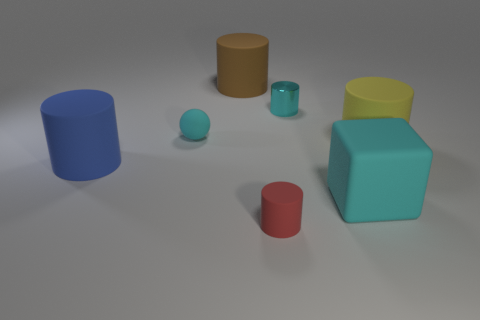Are there any cyan matte spheres of the same size as the yellow cylinder?
Your answer should be very brief. No. There is a thing right of the rubber block; what material is it?
Offer a terse response. Rubber. Do the small cylinder that is behind the blue object and the brown object have the same material?
Your answer should be compact. No. Are there any large blocks?
Give a very brief answer. Yes. The small cylinder that is the same material as the big cyan thing is what color?
Offer a terse response. Red. There is a small rubber object behind the tiny thing that is in front of the cyan matte object to the right of the tiny red thing; what color is it?
Ensure brevity in your answer.  Cyan. Is the size of the metallic cylinder the same as the cyan object in front of the large yellow thing?
Your answer should be compact. No. What number of objects are cylinders on the left side of the large brown rubber cylinder or cyan objects to the right of the small red rubber thing?
Keep it short and to the point. 3. What shape is the brown rubber thing that is the same size as the cyan block?
Offer a terse response. Cylinder. There is a small matte object that is left of the large matte object behind the cyan matte object on the left side of the red matte cylinder; what shape is it?
Keep it short and to the point. Sphere. 